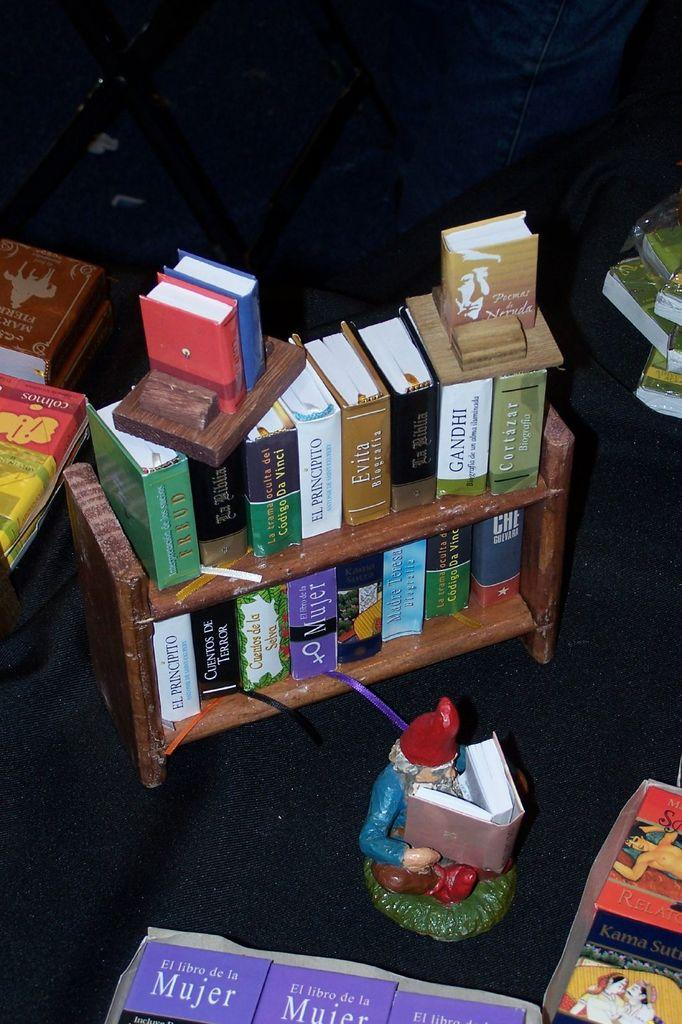<image>
Write a terse but informative summary of the picture. A small bookshelf contains two copies of the book El Principito. 